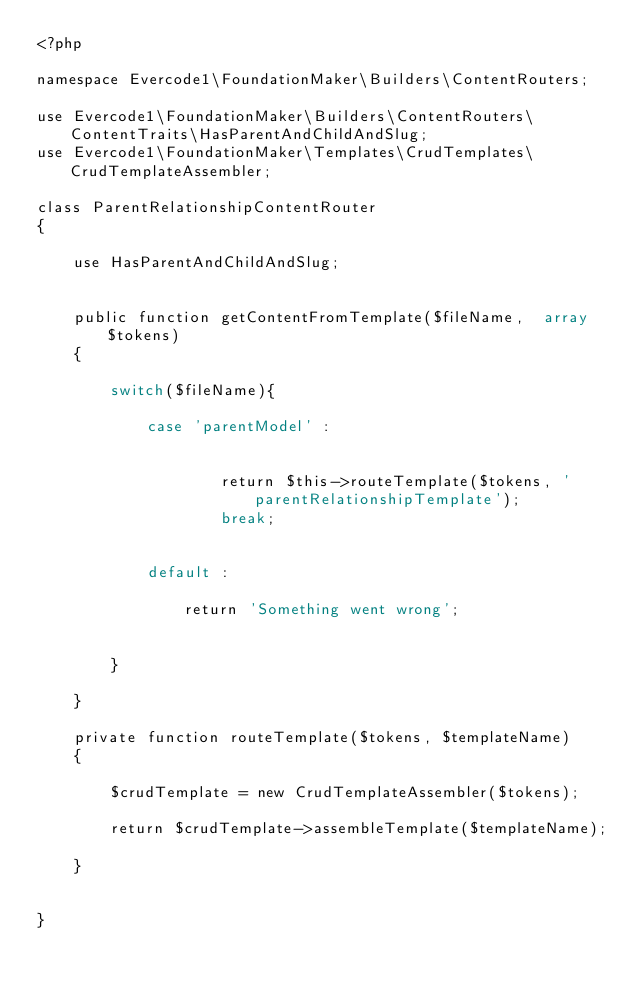Convert code to text. <code><loc_0><loc_0><loc_500><loc_500><_PHP_><?php

namespace Evercode1\FoundationMaker\Builders\ContentRouters;

use Evercode1\FoundationMaker\Builders\ContentRouters\ContentTraits\HasParentAndChildAndSlug;
use Evercode1\FoundationMaker\Templates\CrudTemplates\CrudTemplateAssembler;

class ParentRelationshipContentRouter
{

    use HasParentAndChildAndSlug;


    public function getContentFromTemplate($fileName,  array $tokens)
    {

        switch($fileName){

            case 'parentModel' :


                    return $this->routeTemplate($tokens, 'parentRelationshipTemplate');
                    break;


            default :

                return 'Something went wrong';


        }

    }

    private function routeTemplate($tokens, $templateName)
    {

        $crudTemplate = new CrudTemplateAssembler($tokens);

        return $crudTemplate->assembleTemplate($templateName);

    }


}</code> 